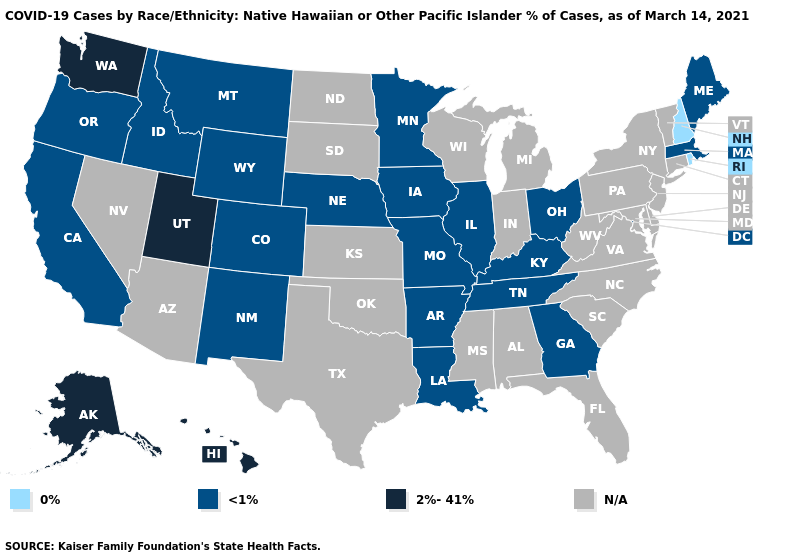What is the lowest value in states that border Nevada?
Short answer required. <1%. What is the value of North Carolina?
Short answer required. N/A. Name the states that have a value in the range N/A?
Be succinct. Alabama, Arizona, Connecticut, Delaware, Florida, Indiana, Kansas, Maryland, Michigan, Mississippi, Nevada, New Jersey, New York, North Carolina, North Dakota, Oklahoma, Pennsylvania, South Carolina, South Dakota, Texas, Vermont, Virginia, West Virginia, Wisconsin. Does Kentucky have the highest value in the USA?
Write a very short answer. No. Does the map have missing data?
Answer briefly. Yes. What is the highest value in the USA?
Be succinct. 2%-41%. Name the states that have a value in the range <1%?
Keep it brief. Arkansas, California, Colorado, Georgia, Idaho, Illinois, Iowa, Kentucky, Louisiana, Maine, Massachusetts, Minnesota, Missouri, Montana, Nebraska, New Mexico, Ohio, Oregon, Tennessee, Wyoming. What is the lowest value in the USA?
Answer briefly. 0%. Does the first symbol in the legend represent the smallest category?
Be succinct. Yes. What is the value of Hawaii?
Keep it brief. 2%-41%. Name the states that have a value in the range 2%-41%?
Answer briefly. Alaska, Hawaii, Utah, Washington. Does the first symbol in the legend represent the smallest category?
Write a very short answer. Yes. 